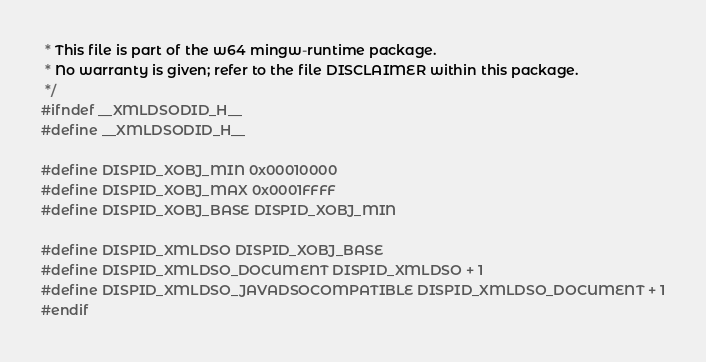<code> <loc_0><loc_0><loc_500><loc_500><_C_> * This file is part of the w64 mingw-runtime package.
 * No warranty is given; refer to the file DISCLAIMER within this package.
 */
#ifndef __XMLDSODID_H__
#define __XMLDSODID_H__

#define DISPID_XOBJ_MIN 0x00010000
#define DISPID_XOBJ_MAX 0x0001FFFF
#define DISPID_XOBJ_BASE DISPID_XOBJ_MIN

#define DISPID_XMLDSO DISPID_XOBJ_BASE
#define DISPID_XMLDSO_DOCUMENT DISPID_XMLDSO + 1
#define DISPID_XMLDSO_JAVADSOCOMPATIBLE DISPID_XMLDSO_DOCUMENT + 1
#endif
</code> 